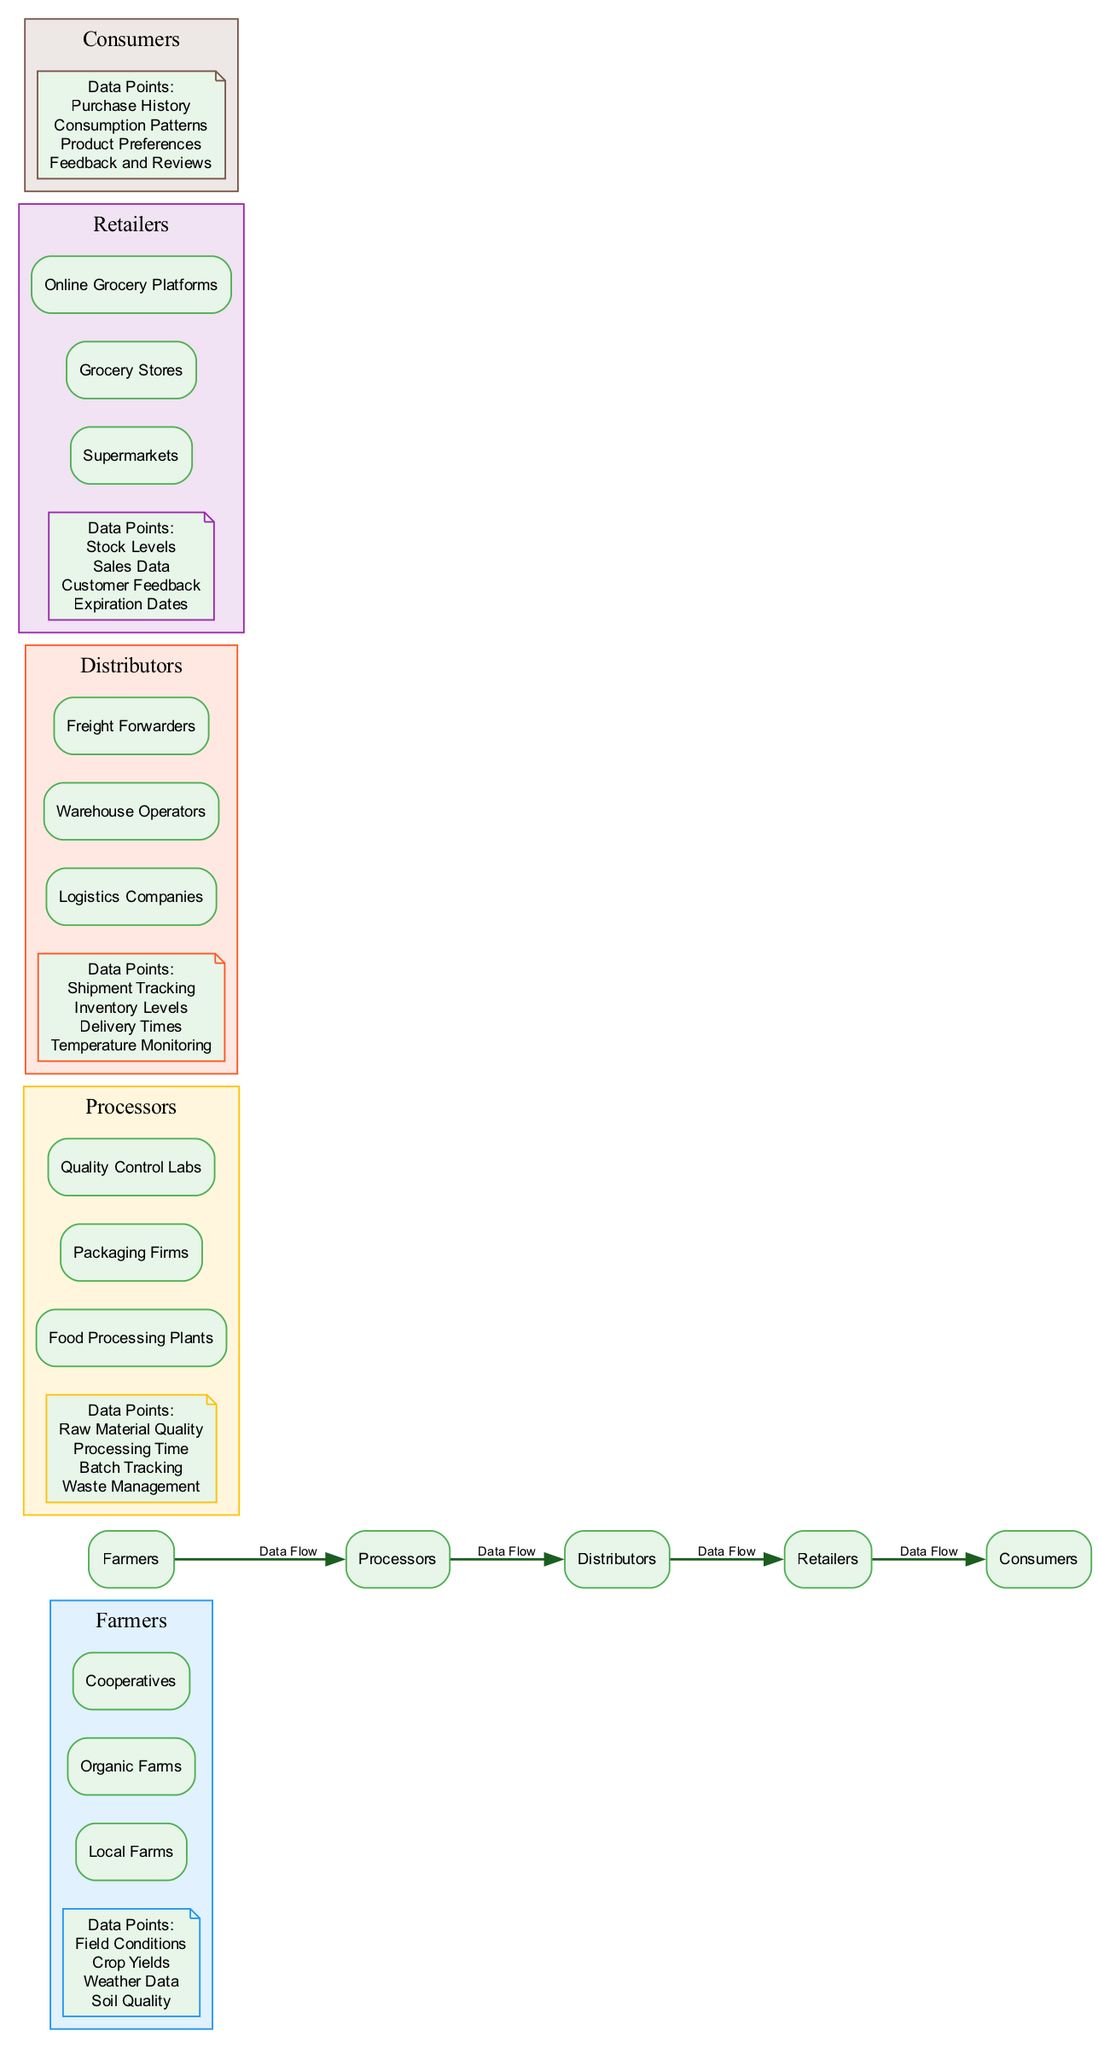What are the data points collected by Farmers? The diagram shows that Farmers collect data points such as Field Conditions, Crop Yields, Weather Data, and Soil Quality. These can be found in the section corresponding to Farmers.
Answer: Field Conditions, Crop Yields, Weather Data, Soil Quality What entities are involved in the Processing stage? The diagram indicates that the entities in the Processing stage are Food Processing Plants, Packaging Firms, and Quality Control Labs. This information can be found in the Processors section.
Answer: Food Processing Plants, Packaging Firms, Quality Control Labs Which stage follows Distributors in the flow? Referring to the data flow in the diagram, Retailers come after Distributors, which indicates the sequence of the food supply chain.
Answer: Retailers How many data points are collected at the Retailers stage? From the diagram, it is clear that Retailers collect four data points: Stock Levels, Sales Data, Customer Feedback, and Expiration Dates. This can be counted from the list in the Retailers section.
Answer: 4 What relationship is established between Farmers and Processors? The diagram explicitly states a 'Data Flow' relationship, indicating that the data from Farmers is passed on to the Processors. This relationship is indicated by an edge connecting these two stages.
Answer: Data Flow What data points are tracked by Distributors? The diagram lists the data points tracked by Distributors as Shipment Tracking, Inventory Levels, Delivery Times, and Temperature Monitoring. This is presented in the Distributors section of the diagram.
Answer: Shipment Tracking, Inventory Levels, Delivery Times, Temperature Monitoring What type of feedback is collected from Consumers? According to the diagram, Consumers provide feedback in the form of Purchase History, Consumption Patterns, Product Preferences, and Feedback and Reviews. This can be seen in the Consumers section.
Answer: Purchase History, Consumption Patterns, Product Preferences, Feedback and Reviews Which entities are responsible for Inventory Levels? The Inventory Levels data point is tracked by the Retailers stage, which includes entities such as Supermarkets, Grocery Stores, and Online Grocery Platforms. This information is found in the Retailers section.
Answer: Supermarkets, Grocery Stores, Online Grocery Platforms What stage involves Waste Management? The diagram specifies that Waste Management is a data point of the Processors stage, indicating their responsibility in managing waste during processing activities.
Answer: Processors 